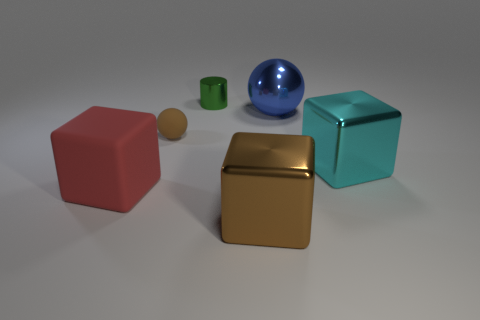Subtract all large cyan blocks. How many blocks are left? 2 Add 1 big cyan metallic things. How many objects exist? 7 Subtract all balls. How many objects are left? 4 Add 4 big blue metallic objects. How many big blue metallic objects exist? 5 Subtract all brown spheres. How many spheres are left? 1 Subtract 1 blue balls. How many objects are left? 5 Subtract all green balls. Subtract all blue cylinders. How many balls are left? 2 Subtract all brown spheres. How many purple cylinders are left? 0 Subtract all small blue blocks. Subtract all metallic objects. How many objects are left? 2 Add 3 big metallic objects. How many big metallic objects are left? 6 